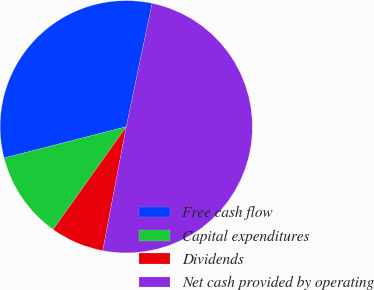<chart> <loc_0><loc_0><loc_500><loc_500><pie_chart><fcel>Free cash flow<fcel>Capital expenditures<fcel>Dividends<fcel>Net cash provided by operating<nl><fcel>32.28%<fcel>11.16%<fcel>6.87%<fcel>49.69%<nl></chart> 